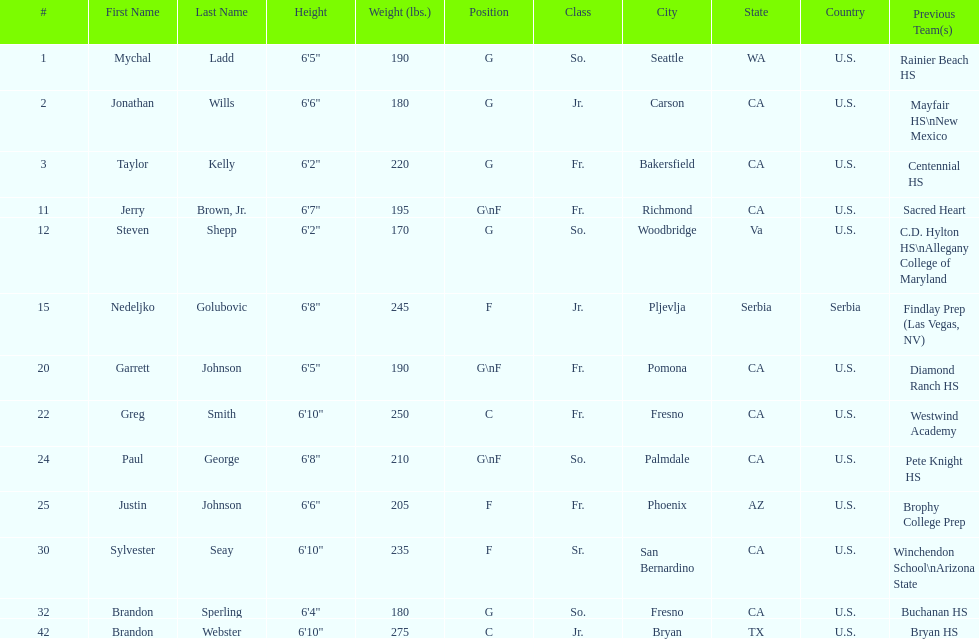What is the number of players who weight over 200 pounds? 7. 